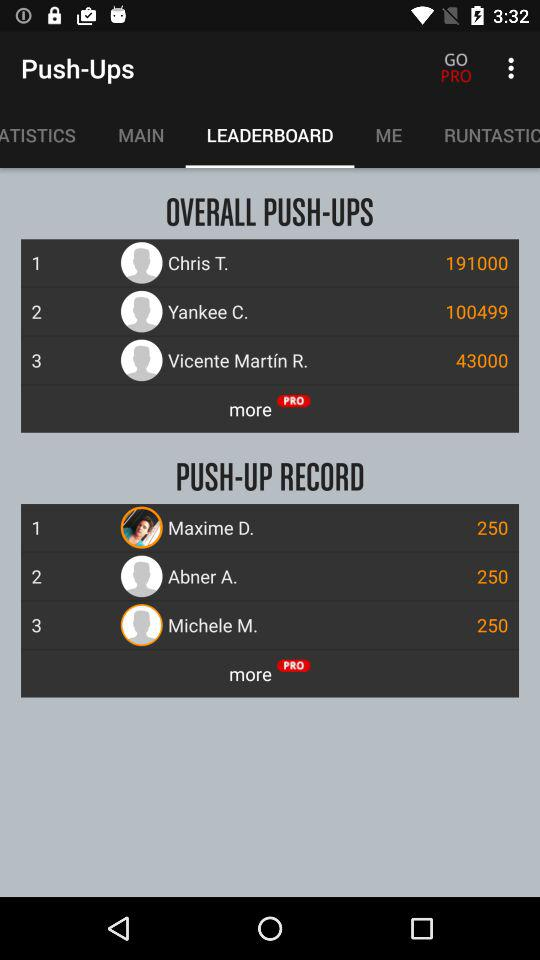What is the "PUSH-UP RECORD" of Maxime D.? The "PUSH-UP RECORD" of Maxime D. is 250. 